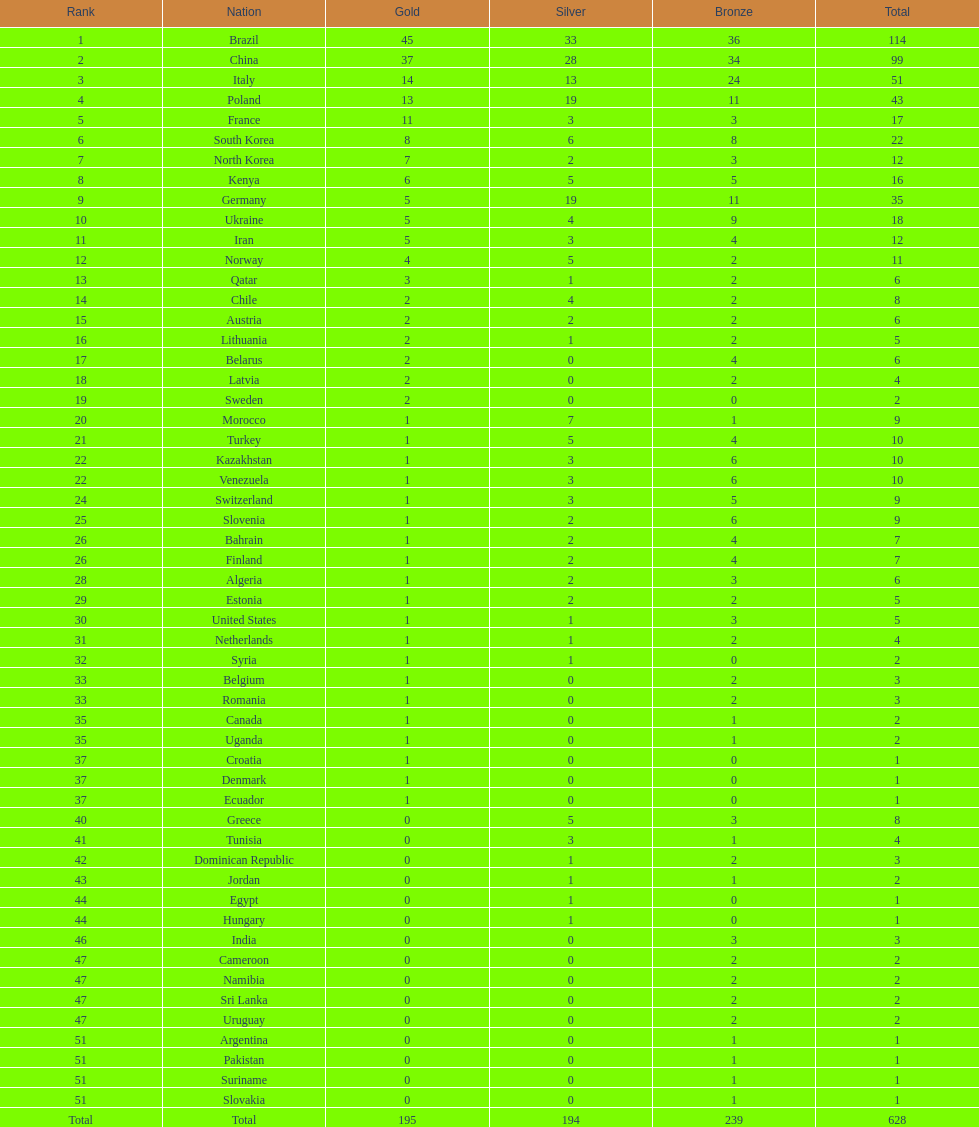How many total medals did norway win? 11. 